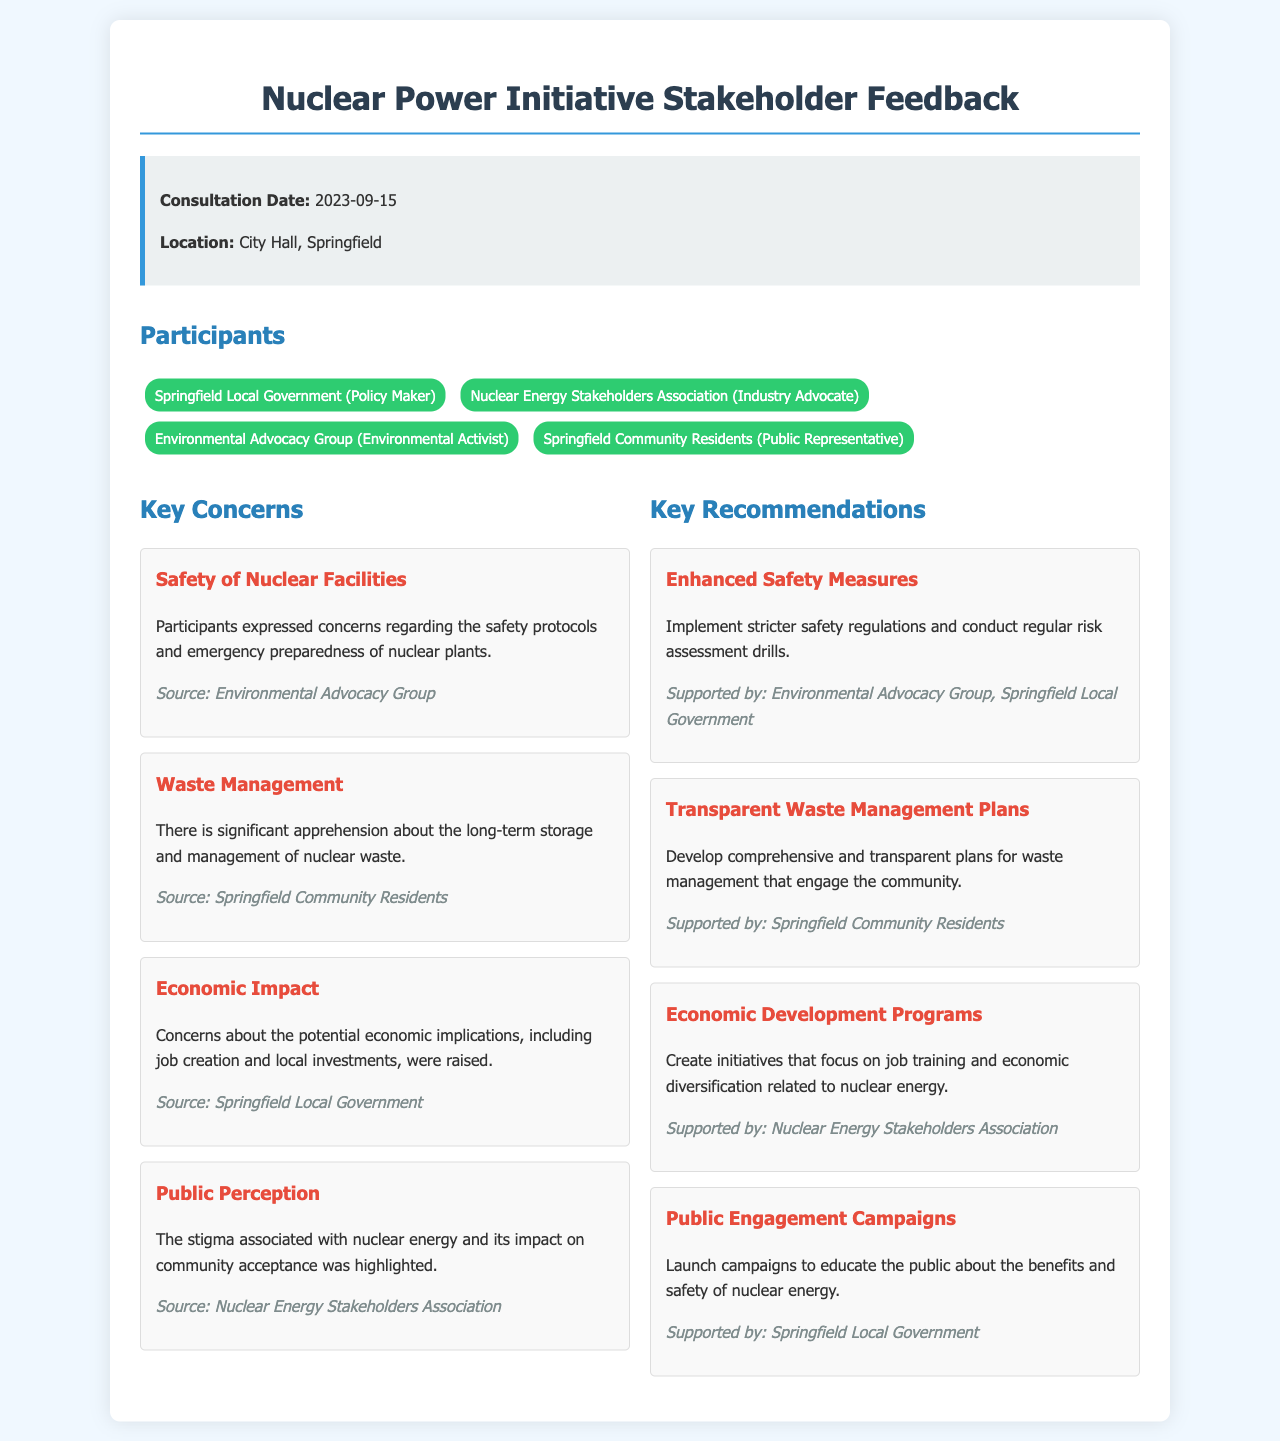what was the consultation date? The consultation date is specifically mentioned in the info box section of the document.
Answer: 2023-09-15 who expressed concerns about safety protocols? The concern about safety protocols was raised by a specific participant type mentioned in the document.
Answer: Environmental Advocacy Group what is one significant concern regarding nuclear waste? This concern is found in the key concerns section, specifically focusing on the management of nuclear waste.
Answer: Long-term storage which local entity supported enhanced safety measures? The support for enhanced safety measures is indicated in the recommendations section, mentioning who backed this recommendation.
Answer: Springfield Local Government how many key recommendations are listed in the document? The document explicitly enumerates the recommendations in a section, allowing for an easy count.
Answer: Four 